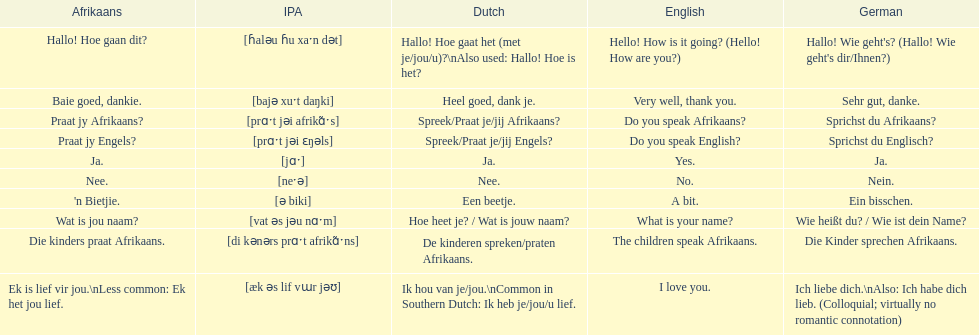How can you inquire if someone speaks afrikaans in afrikaans language? Praat jy Afrikaans?. 